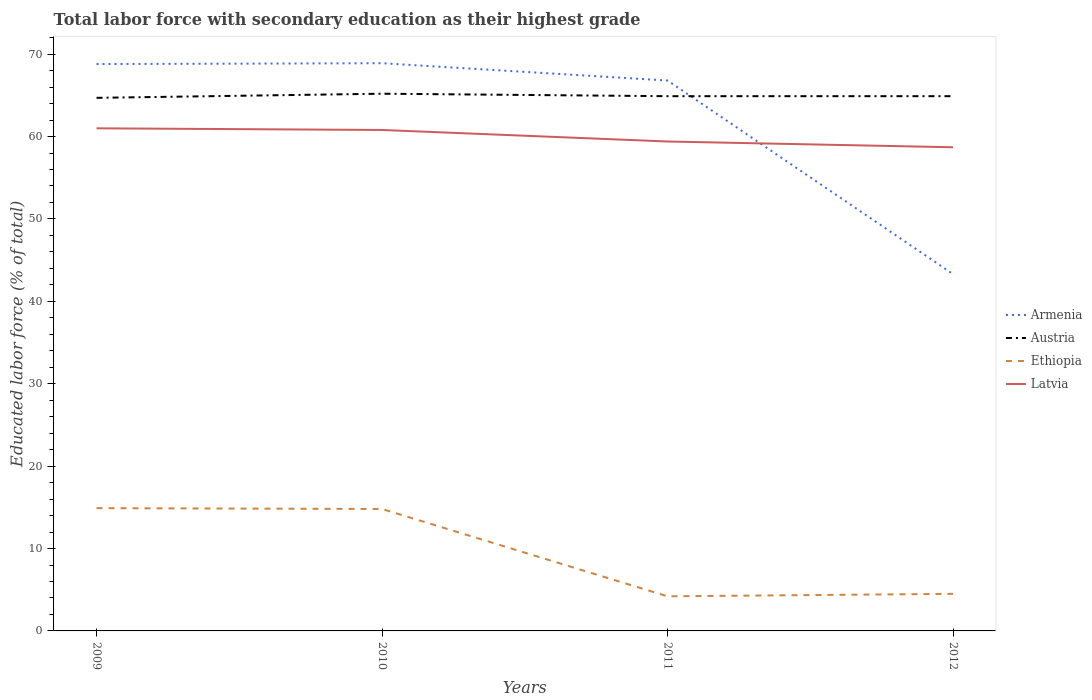Does the line corresponding to Armenia intersect with the line corresponding to Austria?
Offer a very short reply. Yes. Across all years, what is the maximum percentage of total labor force with primary education in Ethiopia?
Offer a very short reply. 4.2. In which year was the percentage of total labor force with primary education in Armenia maximum?
Provide a short and direct response. 2012. What is the total percentage of total labor force with primary education in Latvia in the graph?
Ensure brevity in your answer.  0.2. What is the difference between the highest and the lowest percentage of total labor force with primary education in Ethiopia?
Make the answer very short. 2. How many lines are there?
Your response must be concise. 4. Are the values on the major ticks of Y-axis written in scientific E-notation?
Your answer should be very brief. No. How many legend labels are there?
Your response must be concise. 4. What is the title of the graph?
Make the answer very short. Total labor force with secondary education as their highest grade. What is the label or title of the Y-axis?
Your answer should be very brief. Educated labor force (% of total). What is the Educated labor force (% of total) of Armenia in 2009?
Keep it short and to the point. 68.8. What is the Educated labor force (% of total) in Austria in 2009?
Offer a very short reply. 64.7. What is the Educated labor force (% of total) of Ethiopia in 2009?
Your answer should be very brief. 14.9. What is the Educated labor force (% of total) in Armenia in 2010?
Keep it short and to the point. 68.9. What is the Educated labor force (% of total) of Austria in 2010?
Make the answer very short. 65.2. What is the Educated labor force (% of total) of Ethiopia in 2010?
Your answer should be very brief. 14.8. What is the Educated labor force (% of total) of Latvia in 2010?
Your answer should be compact. 60.8. What is the Educated labor force (% of total) in Armenia in 2011?
Your response must be concise. 66.8. What is the Educated labor force (% of total) of Austria in 2011?
Keep it short and to the point. 64.9. What is the Educated labor force (% of total) in Ethiopia in 2011?
Offer a very short reply. 4.2. What is the Educated labor force (% of total) in Latvia in 2011?
Provide a succinct answer. 59.4. What is the Educated labor force (% of total) in Armenia in 2012?
Ensure brevity in your answer.  43.3. What is the Educated labor force (% of total) of Austria in 2012?
Ensure brevity in your answer.  64.9. What is the Educated labor force (% of total) in Latvia in 2012?
Provide a short and direct response. 58.7. Across all years, what is the maximum Educated labor force (% of total) in Armenia?
Provide a succinct answer. 68.9. Across all years, what is the maximum Educated labor force (% of total) in Austria?
Give a very brief answer. 65.2. Across all years, what is the maximum Educated labor force (% of total) of Ethiopia?
Offer a terse response. 14.9. Across all years, what is the minimum Educated labor force (% of total) in Armenia?
Offer a very short reply. 43.3. Across all years, what is the minimum Educated labor force (% of total) in Austria?
Your response must be concise. 64.7. Across all years, what is the minimum Educated labor force (% of total) in Ethiopia?
Provide a short and direct response. 4.2. Across all years, what is the minimum Educated labor force (% of total) of Latvia?
Your answer should be very brief. 58.7. What is the total Educated labor force (% of total) of Armenia in the graph?
Keep it short and to the point. 247.8. What is the total Educated labor force (% of total) of Austria in the graph?
Make the answer very short. 259.7. What is the total Educated labor force (% of total) of Ethiopia in the graph?
Provide a succinct answer. 38.4. What is the total Educated labor force (% of total) in Latvia in the graph?
Your answer should be compact. 239.9. What is the difference between the Educated labor force (% of total) of Austria in 2009 and that in 2010?
Give a very brief answer. -0.5. What is the difference between the Educated labor force (% of total) in Austria in 2009 and that in 2011?
Keep it short and to the point. -0.2. What is the difference between the Educated labor force (% of total) in Ethiopia in 2009 and that in 2011?
Ensure brevity in your answer.  10.7. What is the difference between the Educated labor force (% of total) of Latvia in 2009 and that in 2011?
Offer a very short reply. 1.6. What is the difference between the Educated labor force (% of total) of Austria in 2009 and that in 2012?
Offer a very short reply. -0.2. What is the difference between the Educated labor force (% of total) of Armenia in 2010 and that in 2011?
Ensure brevity in your answer.  2.1. What is the difference between the Educated labor force (% of total) in Armenia in 2010 and that in 2012?
Offer a terse response. 25.6. What is the difference between the Educated labor force (% of total) of Austria in 2010 and that in 2012?
Your answer should be compact. 0.3. What is the difference between the Educated labor force (% of total) of Ethiopia in 2010 and that in 2012?
Ensure brevity in your answer.  10.3. What is the difference between the Educated labor force (% of total) in Armenia in 2011 and that in 2012?
Keep it short and to the point. 23.5. What is the difference between the Educated labor force (% of total) in Austria in 2011 and that in 2012?
Give a very brief answer. 0. What is the difference between the Educated labor force (% of total) of Ethiopia in 2011 and that in 2012?
Your answer should be very brief. -0.3. What is the difference between the Educated labor force (% of total) of Armenia in 2009 and the Educated labor force (% of total) of Austria in 2010?
Keep it short and to the point. 3.6. What is the difference between the Educated labor force (% of total) of Armenia in 2009 and the Educated labor force (% of total) of Ethiopia in 2010?
Keep it short and to the point. 54. What is the difference between the Educated labor force (% of total) of Austria in 2009 and the Educated labor force (% of total) of Ethiopia in 2010?
Offer a very short reply. 49.9. What is the difference between the Educated labor force (% of total) in Austria in 2009 and the Educated labor force (% of total) in Latvia in 2010?
Ensure brevity in your answer.  3.9. What is the difference between the Educated labor force (% of total) of Ethiopia in 2009 and the Educated labor force (% of total) of Latvia in 2010?
Provide a succinct answer. -45.9. What is the difference between the Educated labor force (% of total) of Armenia in 2009 and the Educated labor force (% of total) of Ethiopia in 2011?
Ensure brevity in your answer.  64.6. What is the difference between the Educated labor force (% of total) in Armenia in 2009 and the Educated labor force (% of total) in Latvia in 2011?
Offer a very short reply. 9.4. What is the difference between the Educated labor force (% of total) of Austria in 2009 and the Educated labor force (% of total) of Ethiopia in 2011?
Ensure brevity in your answer.  60.5. What is the difference between the Educated labor force (% of total) in Ethiopia in 2009 and the Educated labor force (% of total) in Latvia in 2011?
Provide a succinct answer. -44.5. What is the difference between the Educated labor force (% of total) in Armenia in 2009 and the Educated labor force (% of total) in Austria in 2012?
Provide a short and direct response. 3.9. What is the difference between the Educated labor force (% of total) in Armenia in 2009 and the Educated labor force (% of total) in Ethiopia in 2012?
Offer a terse response. 64.3. What is the difference between the Educated labor force (% of total) in Austria in 2009 and the Educated labor force (% of total) in Ethiopia in 2012?
Your answer should be compact. 60.2. What is the difference between the Educated labor force (% of total) in Austria in 2009 and the Educated labor force (% of total) in Latvia in 2012?
Provide a succinct answer. 6. What is the difference between the Educated labor force (% of total) of Ethiopia in 2009 and the Educated labor force (% of total) of Latvia in 2012?
Keep it short and to the point. -43.8. What is the difference between the Educated labor force (% of total) of Armenia in 2010 and the Educated labor force (% of total) of Austria in 2011?
Keep it short and to the point. 4. What is the difference between the Educated labor force (% of total) in Armenia in 2010 and the Educated labor force (% of total) in Ethiopia in 2011?
Offer a terse response. 64.7. What is the difference between the Educated labor force (% of total) of Austria in 2010 and the Educated labor force (% of total) of Ethiopia in 2011?
Keep it short and to the point. 61. What is the difference between the Educated labor force (% of total) of Ethiopia in 2010 and the Educated labor force (% of total) of Latvia in 2011?
Keep it short and to the point. -44.6. What is the difference between the Educated labor force (% of total) in Armenia in 2010 and the Educated labor force (% of total) in Austria in 2012?
Make the answer very short. 4. What is the difference between the Educated labor force (% of total) in Armenia in 2010 and the Educated labor force (% of total) in Ethiopia in 2012?
Your answer should be compact. 64.4. What is the difference between the Educated labor force (% of total) in Austria in 2010 and the Educated labor force (% of total) in Ethiopia in 2012?
Ensure brevity in your answer.  60.7. What is the difference between the Educated labor force (% of total) in Ethiopia in 2010 and the Educated labor force (% of total) in Latvia in 2012?
Ensure brevity in your answer.  -43.9. What is the difference between the Educated labor force (% of total) of Armenia in 2011 and the Educated labor force (% of total) of Ethiopia in 2012?
Provide a succinct answer. 62.3. What is the difference between the Educated labor force (% of total) in Austria in 2011 and the Educated labor force (% of total) in Ethiopia in 2012?
Ensure brevity in your answer.  60.4. What is the difference between the Educated labor force (% of total) of Austria in 2011 and the Educated labor force (% of total) of Latvia in 2012?
Ensure brevity in your answer.  6.2. What is the difference between the Educated labor force (% of total) of Ethiopia in 2011 and the Educated labor force (% of total) of Latvia in 2012?
Keep it short and to the point. -54.5. What is the average Educated labor force (% of total) in Armenia per year?
Keep it short and to the point. 61.95. What is the average Educated labor force (% of total) of Austria per year?
Make the answer very short. 64.92. What is the average Educated labor force (% of total) of Ethiopia per year?
Offer a very short reply. 9.6. What is the average Educated labor force (% of total) in Latvia per year?
Provide a short and direct response. 59.98. In the year 2009, what is the difference between the Educated labor force (% of total) in Armenia and Educated labor force (% of total) in Austria?
Your answer should be very brief. 4.1. In the year 2009, what is the difference between the Educated labor force (% of total) of Armenia and Educated labor force (% of total) of Ethiopia?
Provide a succinct answer. 53.9. In the year 2009, what is the difference between the Educated labor force (% of total) of Austria and Educated labor force (% of total) of Ethiopia?
Keep it short and to the point. 49.8. In the year 2009, what is the difference between the Educated labor force (% of total) in Ethiopia and Educated labor force (% of total) in Latvia?
Provide a short and direct response. -46.1. In the year 2010, what is the difference between the Educated labor force (% of total) in Armenia and Educated labor force (% of total) in Ethiopia?
Your response must be concise. 54.1. In the year 2010, what is the difference between the Educated labor force (% of total) in Austria and Educated labor force (% of total) in Ethiopia?
Make the answer very short. 50.4. In the year 2010, what is the difference between the Educated labor force (% of total) in Austria and Educated labor force (% of total) in Latvia?
Your answer should be very brief. 4.4. In the year 2010, what is the difference between the Educated labor force (% of total) in Ethiopia and Educated labor force (% of total) in Latvia?
Your answer should be very brief. -46. In the year 2011, what is the difference between the Educated labor force (% of total) of Armenia and Educated labor force (% of total) of Ethiopia?
Give a very brief answer. 62.6. In the year 2011, what is the difference between the Educated labor force (% of total) in Armenia and Educated labor force (% of total) in Latvia?
Your response must be concise. 7.4. In the year 2011, what is the difference between the Educated labor force (% of total) of Austria and Educated labor force (% of total) of Ethiopia?
Your answer should be compact. 60.7. In the year 2011, what is the difference between the Educated labor force (% of total) in Ethiopia and Educated labor force (% of total) in Latvia?
Your answer should be compact. -55.2. In the year 2012, what is the difference between the Educated labor force (% of total) in Armenia and Educated labor force (% of total) in Austria?
Provide a short and direct response. -21.6. In the year 2012, what is the difference between the Educated labor force (% of total) of Armenia and Educated labor force (% of total) of Ethiopia?
Your response must be concise. 38.8. In the year 2012, what is the difference between the Educated labor force (% of total) of Armenia and Educated labor force (% of total) of Latvia?
Make the answer very short. -15.4. In the year 2012, what is the difference between the Educated labor force (% of total) in Austria and Educated labor force (% of total) in Ethiopia?
Provide a short and direct response. 60.4. In the year 2012, what is the difference between the Educated labor force (% of total) in Austria and Educated labor force (% of total) in Latvia?
Your answer should be very brief. 6.2. In the year 2012, what is the difference between the Educated labor force (% of total) in Ethiopia and Educated labor force (% of total) in Latvia?
Your answer should be compact. -54.2. What is the ratio of the Educated labor force (% of total) of Armenia in 2009 to that in 2010?
Keep it short and to the point. 1. What is the ratio of the Educated labor force (% of total) in Ethiopia in 2009 to that in 2010?
Your response must be concise. 1.01. What is the ratio of the Educated labor force (% of total) of Latvia in 2009 to that in 2010?
Ensure brevity in your answer.  1. What is the ratio of the Educated labor force (% of total) of Armenia in 2009 to that in 2011?
Your response must be concise. 1.03. What is the ratio of the Educated labor force (% of total) in Ethiopia in 2009 to that in 2011?
Make the answer very short. 3.55. What is the ratio of the Educated labor force (% of total) in Latvia in 2009 to that in 2011?
Give a very brief answer. 1.03. What is the ratio of the Educated labor force (% of total) in Armenia in 2009 to that in 2012?
Provide a short and direct response. 1.59. What is the ratio of the Educated labor force (% of total) of Ethiopia in 2009 to that in 2012?
Ensure brevity in your answer.  3.31. What is the ratio of the Educated labor force (% of total) of Latvia in 2009 to that in 2012?
Offer a very short reply. 1.04. What is the ratio of the Educated labor force (% of total) of Armenia in 2010 to that in 2011?
Keep it short and to the point. 1.03. What is the ratio of the Educated labor force (% of total) of Ethiopia in 2010 to that in 2011?
Ensure brevity in your answer.  3.52. What is the ratio of the Educated labor force (% of total) of Latvia in 2010 to that in 2011?
Your response must be concise. 1.02. What is the ratio of the Educated labor force (% of total) in Armenia in 2010 to that in 2012?
Make the answer very short. 1.59. What is the ratio of the Educated labor force (% of total) of Ethiopia in 2010 to that in 2012?
Provide a short and direct response. 3.29. What is the ratio of the Educated labor force (% of total) in Latvia in 2010 to that in 2012?
Provide a succinct answer. 1.04. What is the ratio of the Educated labor force (% of total) in Armenia in 2011 to that in 2012?
Make the answer very short. 1.54. What is the ratio of the Educated labor force (% of total) in Latvia in 2011 to that in 2012?
Provide a succinct answer. 1.01. What is the difference between the highest and the second highest Educated labor force (% of total) in Armenia?
Provide a succinct answer. 0.1. What is the difference between the highest and the second highest Educated labor force (% of total) of Ethiopia?
Keep it short and to the point. 0.1. What is the difference between the highest and the lowest Educated labor force (% of total) of Armenia?
Provide a succinct answer. 25.6. What is the difference between the highest and the lowest Educated labor force (% of total) in Austria?
Your answer should be very brief. 0.5. What is the difference between the highest and the lowest Educated labor force (% of total) in Ethiopia?
Your response must be concise. 10.7. 